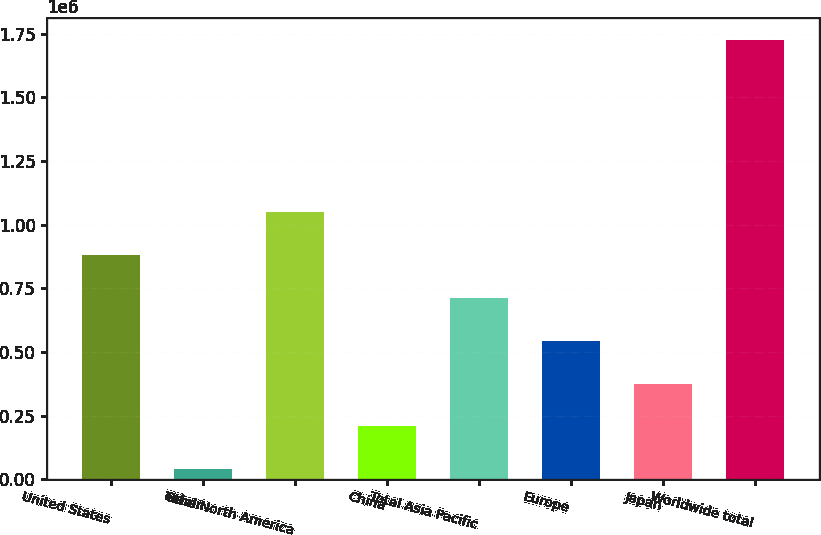Convert chart to OTSL. <chart><loc_0><loc_0><loc_500><loc_500><bar_chart><fcel>United States<fcel>Other<fcel>Total North America<fcel>China<fcel>Total Asia Pacific<fcel>Europe<fcel>Japan<fcel>Worldwide total<nl><fcel>882162<fcel>38074<fcel>1.05098e+06<fcel>206892<fcel>713344<fcel>544527<fcel>375709<fcel>1.72625e+06<nl></chart> 